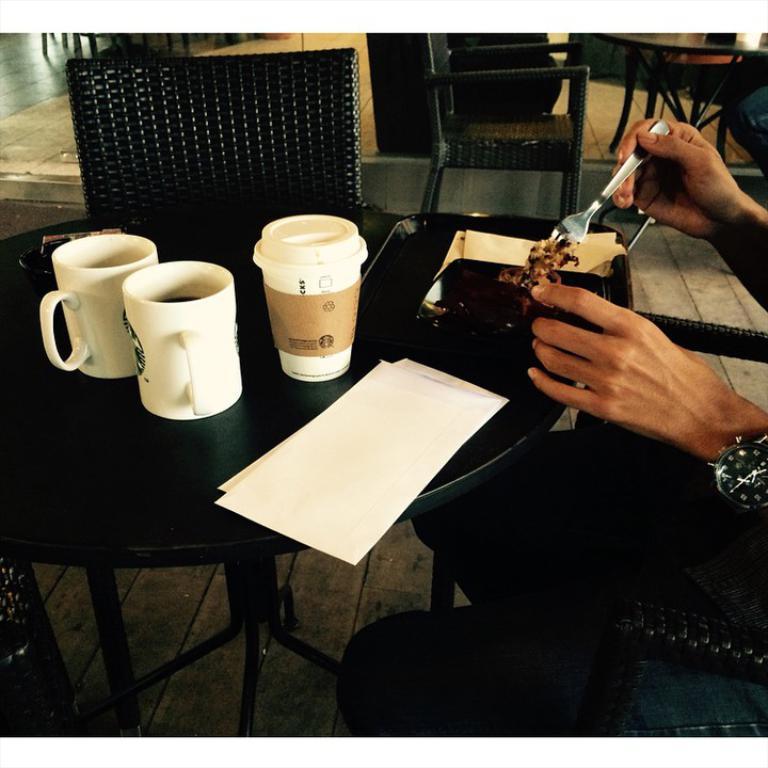In one or two sentences, can you explain what this image depicts? There is a table which has some eatables and drinks and papers on it and there is a hands of a person in the right corner. 